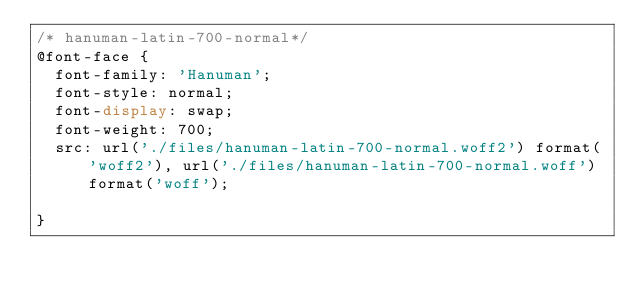<code> <loc_0><loc_0><loc_500><loc_500><_CSS_>/* hanuman-latin-700-normal*/
@font-face {
  font-family: 'Hanuman';
  font-style: normal;
  font-display: swap;
  font-weight: 700;
  src: url('./files/hanuman-latin-700-normal.woff2') format('woff2'), url('./files/hanuman-latin-700-normal.woff') format('woff');
  
}
</code> 